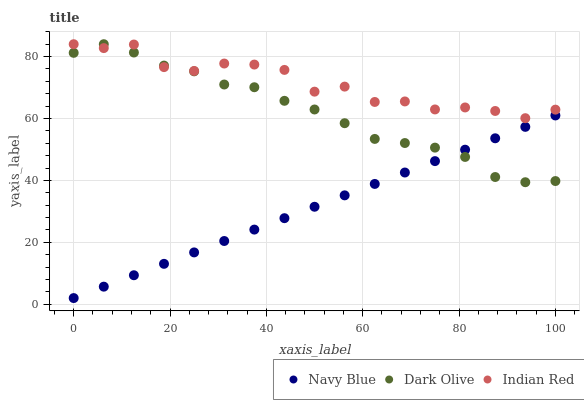Does Navy Blue have the minimum area under the curve?
Answer yes or no. Yes. Does Indian Red have the maximum area under the curve?
Answer yes or no. Yes. Does Dark Olive have the minimum area under the curve?
Answer yes or no. No. Does Dark Olive have the maximum area under the curve?
Answer yes or no. No. Is Navy Blue the smoothest?
Answer yes or no. Yes. Is Indian Red the roughest?
Answer yes or no. Yes. Is Dark Olive the smoothest?
Answer yes or no. No. Is Dark Olive the roughest?
Answer yes or no. No. Does Navy Blue have the lowest value?
Answer yes or no. Yes. Does Dark Olive have the lowest value?
Answer yes or no. No. Does Indian Red have the highest value?
Answer yes or no. Yes. Is Navy Blue less than Indian Red?
Answer yes or no. Yes. Is Indian Red greater than Navy Blue?
Answer yes or no. Yes. Does Indian Red intersect Dark Olive?
Answer yes or no. Yes. Is Indian Red less than Dark Olive?
Answer yes or no. No. Is Indian Red greater than Dark Olive?
Answer yes or no. No. Does Navy Blue intersect Indian Red?
Answer yes or no. No. 